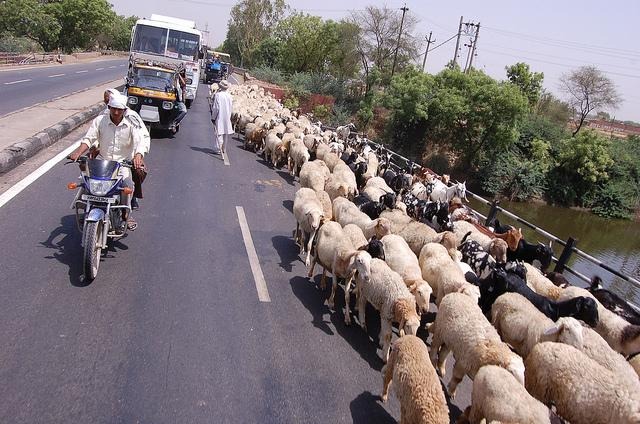What is clogging up the street? Please explain your reasoning. animals. The animals clog. 